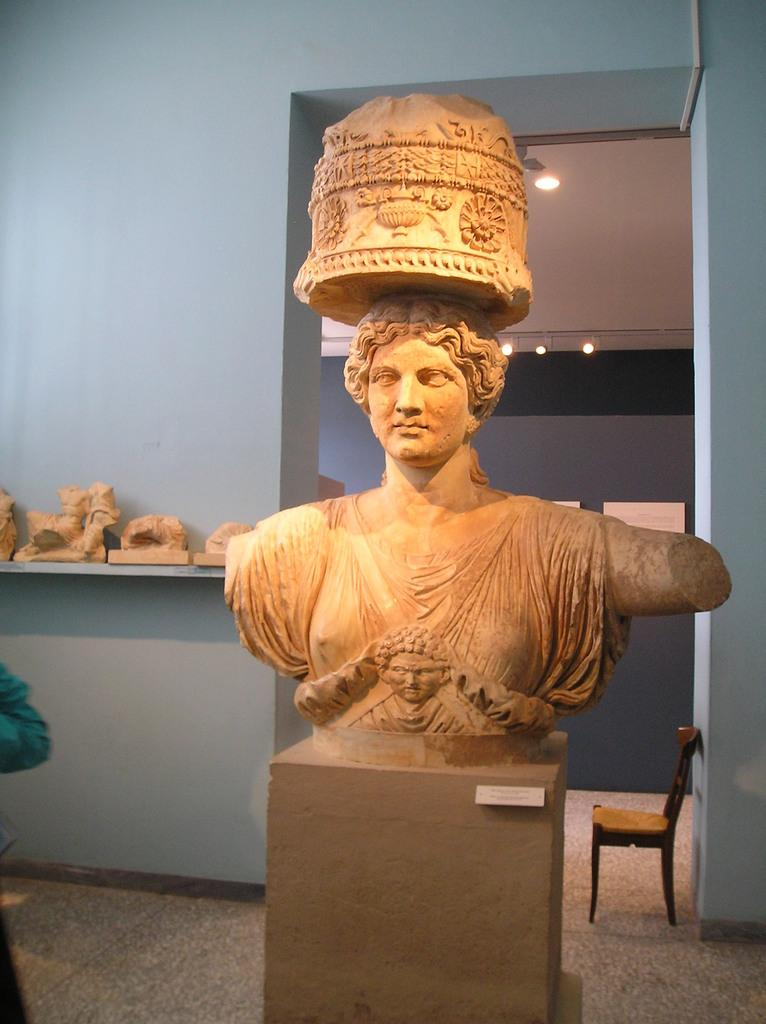Where is the setting of the image? The image is inside a room. What can be seen in the room? There is a statue and a wall visible in the image. Are there any other statues in the room? Yes, there are statues on a shelf in the background. What can be used for illumination in the room? There are lights in the room. What type of furniture is present in the room? There is a chair on the floor in the room. What type of bread can be seen on the shelf in the image? There is no bread present in the image; it features statues on a shelf in the background. What type of silk material is draped over the statue in the image? There is no silk material present in the image; the statue is not covered or draped with any fabric. 